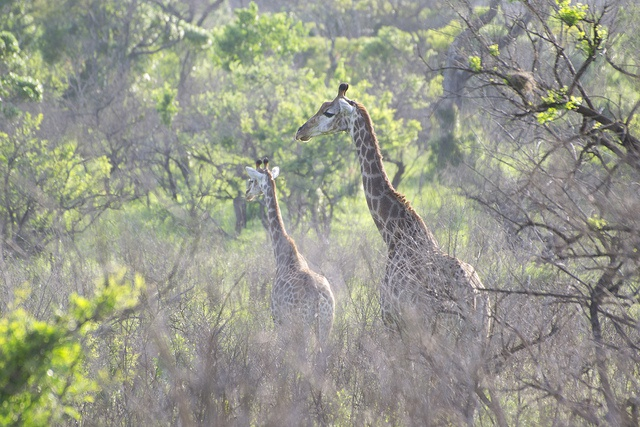Describe the objects in this image and their specific colors. I can see giraffe in gray tones and giraffe in gray, darkgray, and lightgray tones in this image. 